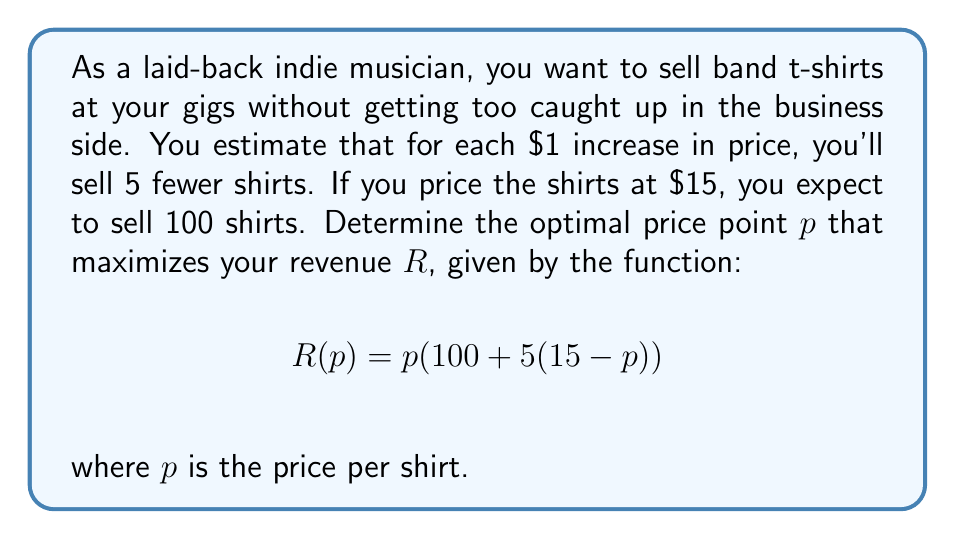Can you solve this math problem? Let's approach this step-by-step:

1) First, let's expand the revenue function:
   $$R(p) = p(100 + 75 - 5p) = p(175 - 5p) = 175p - 5p^2$$

2) To find the maximum revenue, we need to find the vertex of this quadratic function. We can do this by finding where the derivative equals zero.

3) Let's take the derivative of $R$ with respect to $p$:
   $$R'(p) = 175 - 10p$$

4) Set this equal to zero and solve for $p$:
   $$175 - 10p = 0$$
   $$-10p = -175$$
   $$p = 17.5$$

5) To confirm this is a maximum (not a minimum), we can check that the second derivative is negative:
   $$R''(p) = -10$$
   Since this is negative, we confirm that $p = 17.5$ gives a maximum.

6) Therefore, the optimal price point is $17.50 per shirt.

7) We can calculate the maximum revenue at this price:
   $$R(17.5) = 175(17.5) - 5(17.5)^2 = 3062.5 - 1531.25 = 1531.25$$
Answer: The optimal price point is $17.50 per shirt, which will generate a maximum revenue of $1531.25. 